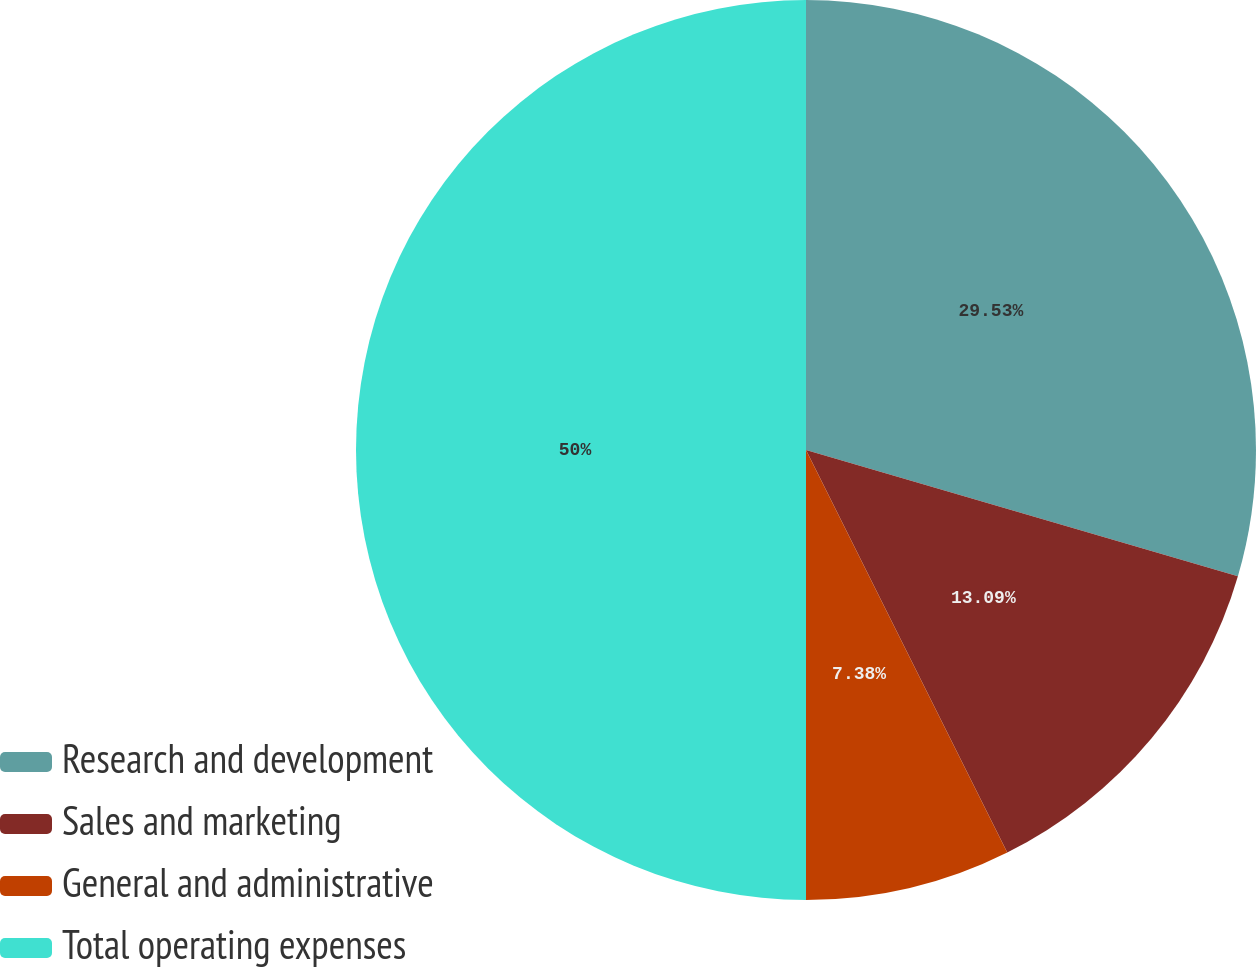<chart> <loc_0><loc_0><loc_500><loc_500><pie_chart><fcel>Research and development<fcel>Sales and marketing<fcel>General and administrative<fcel>Total operating expenses<nl><fcel>29.53%<fcel>13.09%<fcel>7.38%<fcel>50.0%<nl></chart> 